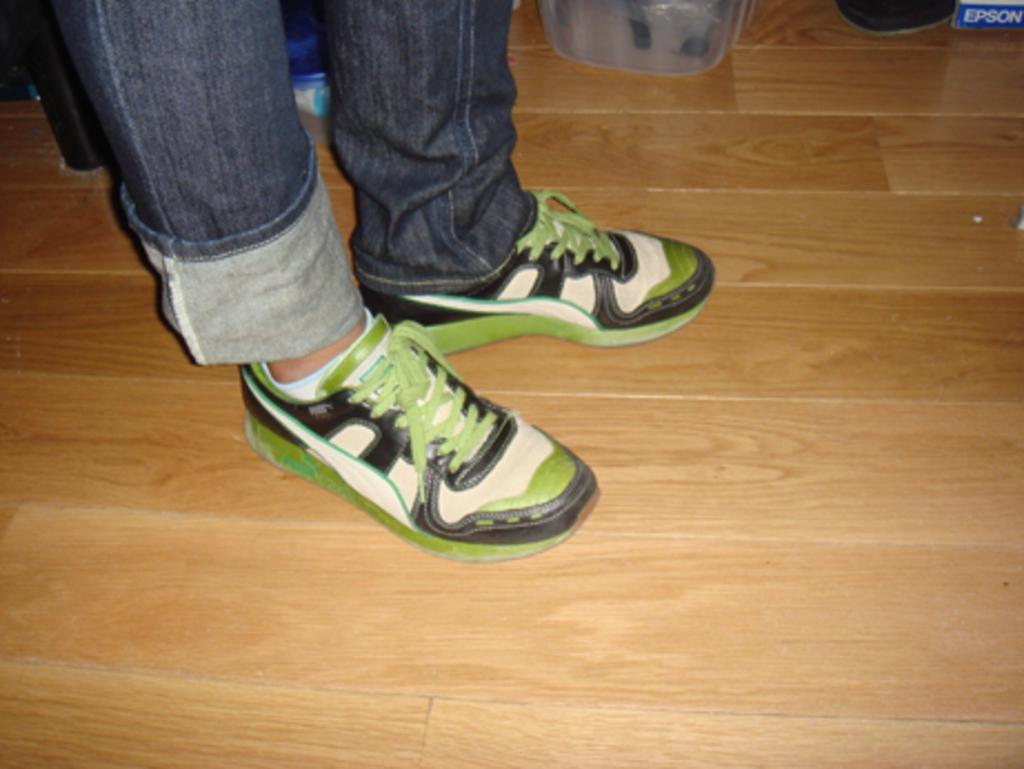What part of a person can be seen in the image? There are a person's legs visible in the image. What type of footwear is the person wearing? The person is wearing shoes. What material is the floor made of? The floor is made of wood. Can you describe any objects or items in the image? There are some items in the image, but their specific nature is not mentioned in the provided facts. What type of prison can be seen in the image? There is no prison present in the image; it only shows a person's legs, shoes, and a wooden floor. What is the best way to reach the vase in the image? There is no vase present in the image, so it is not possible to determine the best way to reach it. 